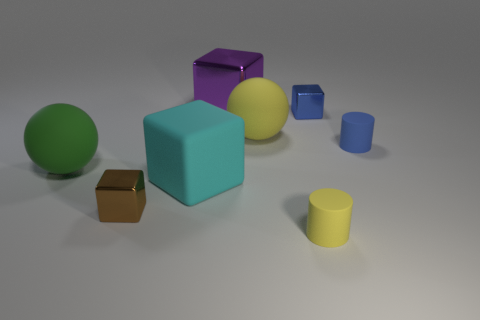There is a small cylinder in front of the cube that is in front of the cyan matte object; what is its color?
Your response must be concise. Yellow. What number of matte objects are green objects or tiny yellow cylinders?
Offer a very short reply. 2. Is there another big green sphere made of the same material as the green sphere?
Provide a short and direct response. No. What number of metallic blocks are both on the left side of the small yellow object and behind the blue cylinder?
Keep it short and to the point. 1. Are there fewer green spheres to the right of the big yellow sphere than shiny objects to the left of the big cyan rubber object?
Offer a terse response. Yes. Do the big green matte thing and the big yellow rubber thing have the same shape?
Your answer should be compact. Yes. How many other objects are there of the same size as the purple metallic thing?
Your answer should be compact. 3. How many things are either yellow rubber objects that are left of the yellow cylinder or blocks to the right of the big purple thing?
Your answer should be compact. 2. What number of cyan metal objects are the same shape as the purple object?
Your answer should be compact. 0. The thing that is to the left of the large yellow matte sphere and in front of the cyan cube is made of what material?
Ensure brevity in your answer.  Metal. 